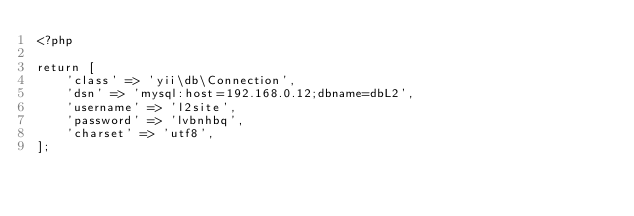Convert code to text. <code><loc_0><loc_0><loc_500><loc_500><_PHP_><?php

return [
    'class' => 'yii\db\Connection',
    'dsn' => 'mysql:host=192.168.0.12;dbname=dbL2',
    'username' => 'l2site',
    'password' => 'lvbnhbq',
    'charset' => 'utf8',
];
</code> 